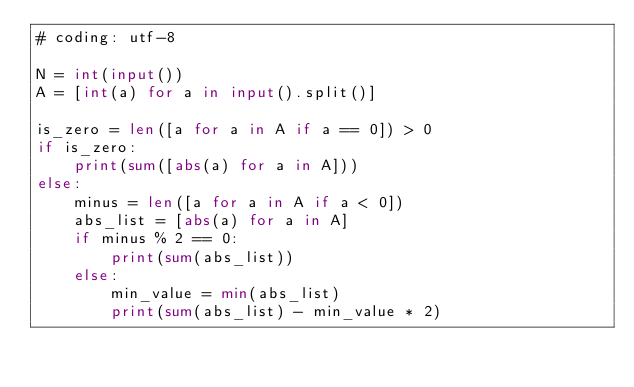Convert code to text. <code><loc_0><loc_0><loc_500><loc_500><_Python_># coding: utf-8

N = int(input())
A = [int(a) for a in input().split()]

is_zero = len([a for a in A if a == 0]) > 0
if is_zero:
    print(sum([abs(a) for a in A]))
else:
    minus = len([a for a in A if a < 0])
    abs_list = [abs(a) for a in A]
    if minus % 2 == 0:
        print(sum(abs_list))
    else:
        min_value = min(abs_list)
        print(sum(abs_list) - min_value * 2)
</code> 